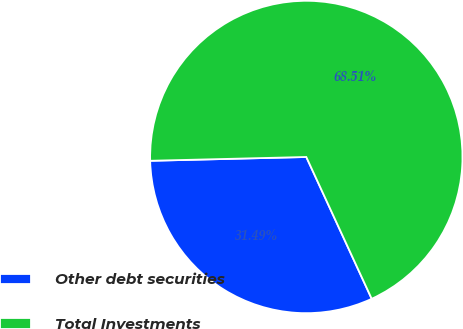Convert chart to OTSL. <chart><loc_0><loc_0><loc_500><loc_500><pie_chart><fcel>Other debt securities<fcel>Total Investments<nl><fcel>31.49%<fcel>68.51%<nl></chart> 